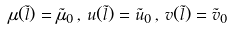Convert formula to latex. <formula><loc_0><loc_0><loc_500><loc_500>\mu ( { \tilde { l } } ) = { \tilde { \mu } } _ { 0 } \, , \, u ( { \tilde { l } } ) = { \tilde { u } } _ { 0 } \, , \, v ( { \tilde { l } } ) = { \tilde { v } } _ { 0 }</formula> 